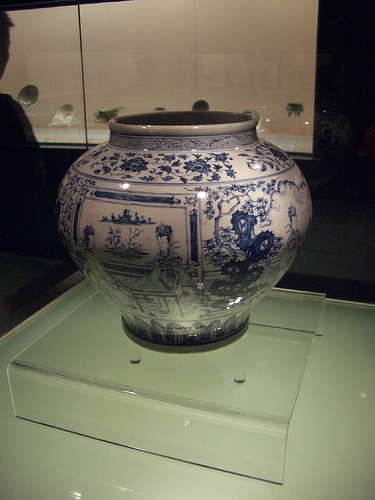Describe the objects in this image and their specific colors. I can see vase in black, gray, and darkgray tones and people in black and gray tones in this image. 